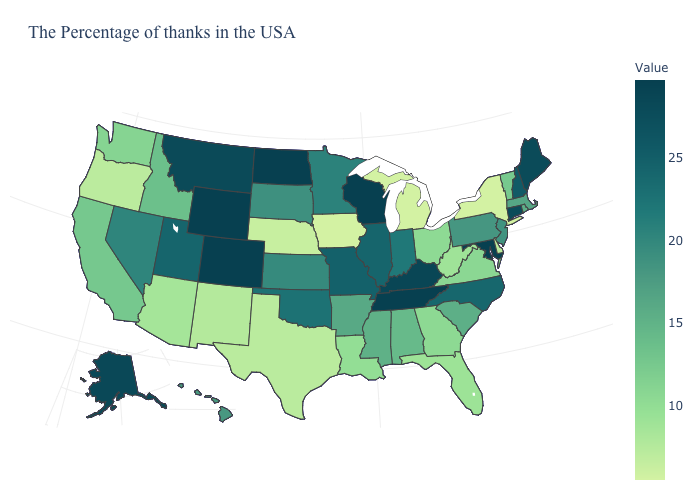Does the map have missing data?
Keep it brief. No. Which states have the lowest value in the MidWest?
Be succinct. Michigan, Iowa. Does Maine have the highest value in the Northeast?
Give a very brief answer. Yes. Among the states that border Washington , does Idaho have the highest value?
Answer briefly. Yes. Which states hav the highest value in the West?
Concise answer only. Wyoming, Colorado. 